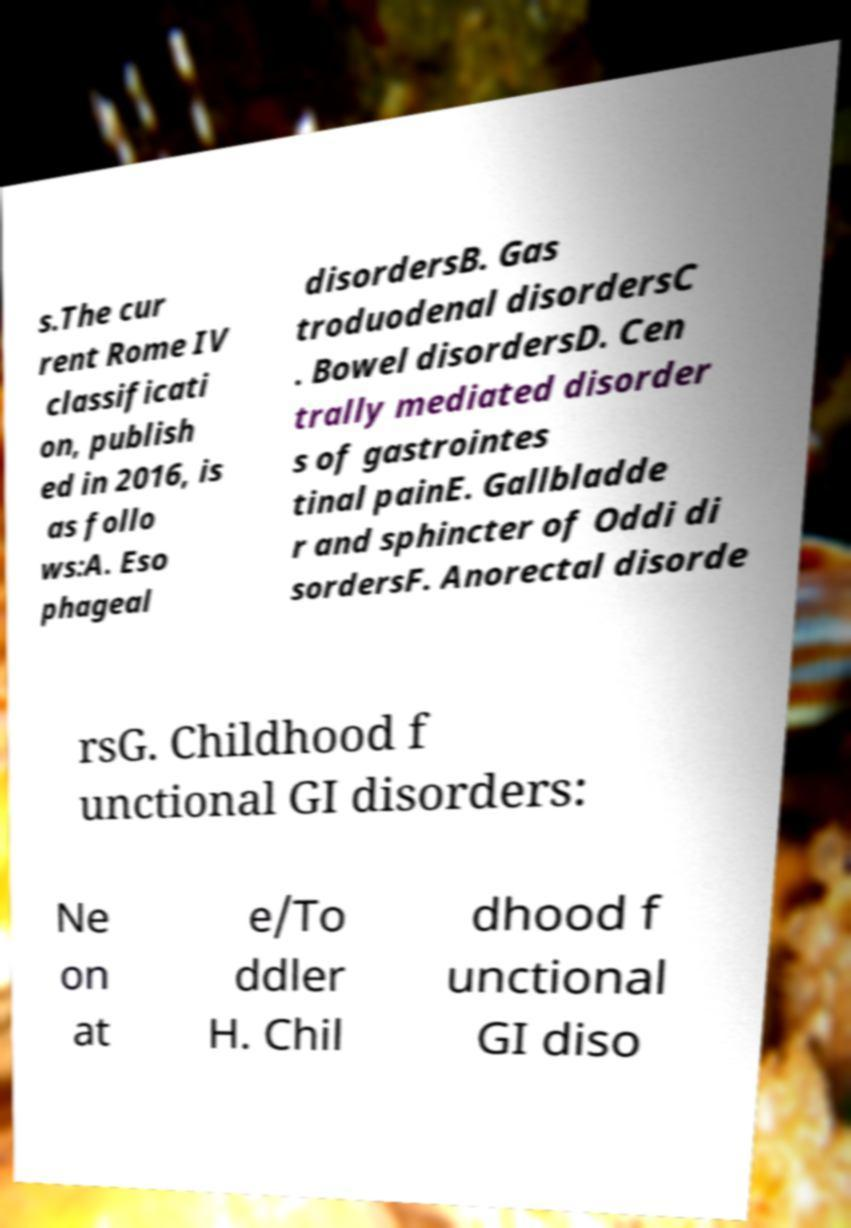Could you extract and type out the text from this image? s.The cur rent Rome IV classificati on, publish ed in 2016, is as follo ws:A. Eso phageal disordersB. Gas troduodenal disordersC . Bowel disordersD. Cen trally mediated disorder s of gastrointes tinal painE. Gallbladde r and sphincter of Oddi di sordersF. Anorectal disorde rsG. Childhood f unctional GI disorders: Ne on at e/To ddler H. Chil dhood f unctional GI diso 